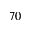<formula> <loc_0><loc_0><loc_500><loc_500>7 0</formula> 